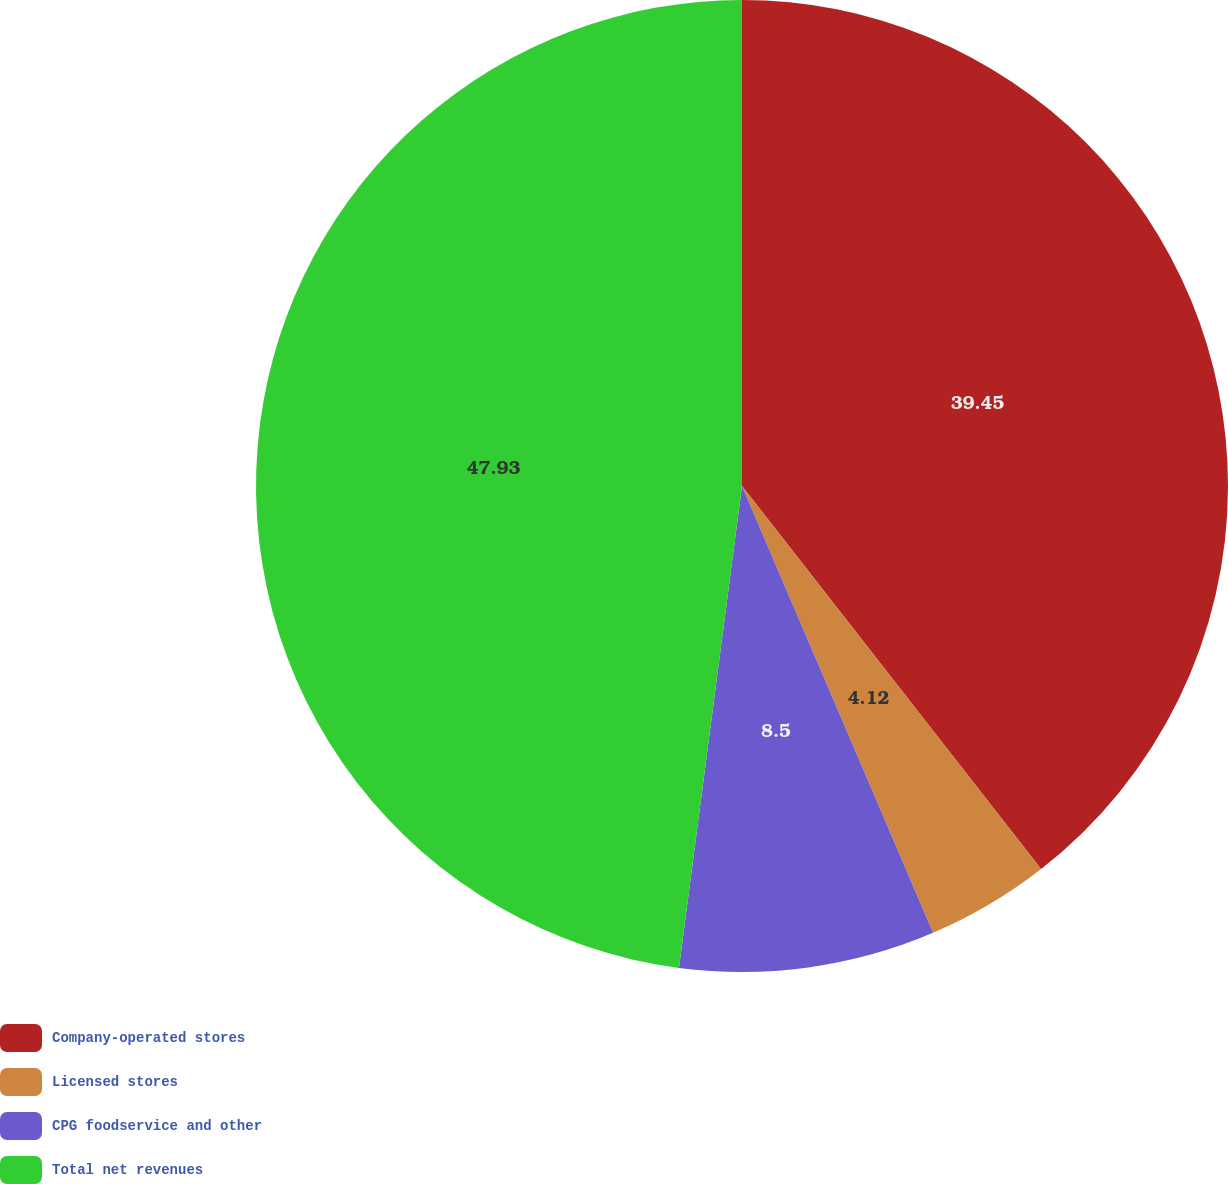<chart> <loc_0><loc_0><loc_500><loc_500><pie_chart><fcel>Company-operated stores<fcel>Licensed stores<fcel>CPG foodservice and other<fcel>Total net revenues<nl><fcel>39.45%<fcel>4.12%<fcel>8.5%<fcel>47.93%<nl></chart> 